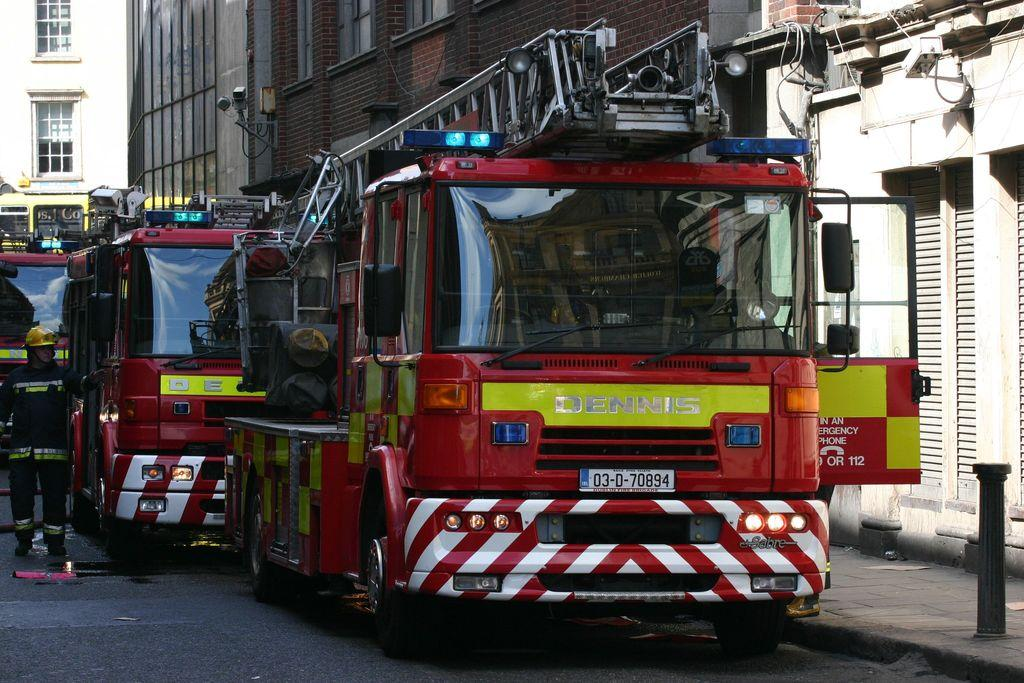What types of objects can be seen in the image? There are vehicles, street lamps, and buildings in the image. Can you describe any specific features of the buildings? The buildings have windows, as mentioned in the image. What might be used to provide light at night in the image? The street lamps in the image provide light at night. Is there any sleet visible in the image? There is no mention of sleet in the provided facts, so it cannot be determined if sleet is present in the image. Can you describe how the buildings change color throughout the day in the image? The provided facts do not mention any changes in the color of the buildings, so it cannot be determined if they change color throughout the day. 